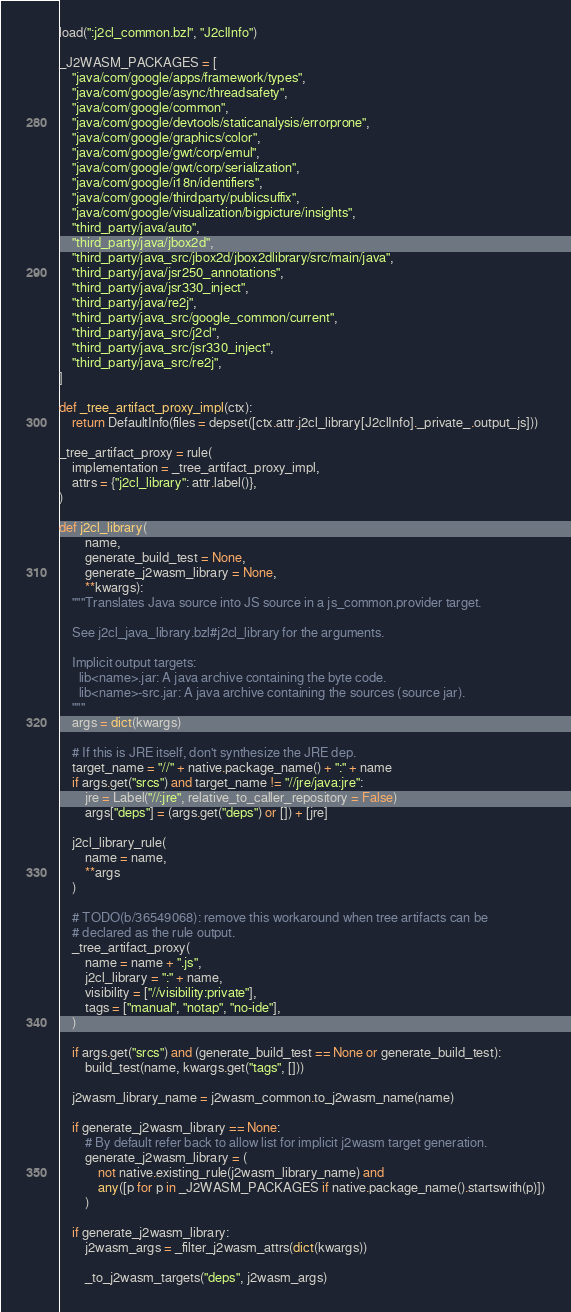Convert code to text. <code><loc_0><loc_0><loc_500><loc_500><_Python_>load(":j2cl_common.bzl", "J2clInfo")

_J2WASM_PACKAGES = [
    "java/com/google/apps/framework/types",
    "java/com/google/async/threadsafety",
    "java/com/google/common",
    "java/com/google/devtools/staticanalysis/errorprone",
    "java/com/google/graphics/color",
    "java/com/google/gwt/corp/emul",
    "java/com/google/gwt/corp/serialization",
    "java/com/google/i18n/identifiers",
    "java/com/google/thirdparty/publicsuffix",
    "java/com/google/visualization/bigpicture/insights",
    "third_party/java/auto",
    "third_party/java/jbox2d",
    "third_party/java_src/jbox2d/jbox2dlibrary/src/main/java",
    "third_party/java/jsr250_annotations",
    "third_party/java/jsr330_inject",
    "third_party/java/re2j",
    "third_party/java_src/google_common/current",
    "third_party/java_src/j2cl",
    "third_party/java_src/jsr330_inject",
    "third_party/java_src/re2j",
]

def _tree_artifact_proxy_impl(ctx):
    return DefaultInfo(files = depset([ctx.attr.j2cl_library[J2clInfo]._private_.output_js]))

_tree_artifact_proxy = rule(
    implementation = _tree_artifact_proxy_impl,
    attrs = {"j2cl_library": attr.label()},
)

def j2cl_library(
        name,
        generate_build_test = None,
        generate_j2wasm_library = None,
        **kwargs):
    """Translates Java source into JS source in a js_common.provider target.

    See j2cl_java_library.bzl#j2cl_library for the arguments.

    Implicit output targets:
      lib<name>.jar: A java archive containing the byte code.
      lib<name>-src.jar: A java archive containing the sources (source jar).
    """
    args = dict(kwargs)

    # If this is JRE itself, don't synthesize the JRE dep.
    target_name = "//" + native.package_name() + ":" + name
    if args.get("srcs") and target_name != "//jre/java:jre":
        jre = Label("//:jre", relative_to_caller_repository = False)
        args["deps"] = (args.get("deps") or []) + [jre]

    j2cl_library_rule(
        name = name,
        **args
    )

    # TODO(b/36549068): remove this workaround when tree artifacts can be
    # declared as the rule output.
    _tree_artifact_proxy(
        name = name + ".js",
        j2cl_library = ":" + name,
        visibility = ["//visibility:private"],
        tags = ["manual", "notap", "no-ide"],
    )

    if args.get("srcs") and (generate_build_test == None or generate_build_test):
        build_test(name, kwargs.get("tags", []))

    j2wasm_library_name = j2wasm_common.to_j2wasm_name(name)

    if generate_j2wasm_library == None:
        # By default refer back to allow list for implicit j2wasm target generation.
        generate_j2wasm_library = (
            not native.existing_rule(j2wasm_library_name) and
            any([p for p in _J2WASM_PACKAGES if native.package_name().startswith(p)])
        )

    if generate_j2wasm_library:
        j2wasm_args = _filter_j2wasm_attrs(dict(kwargs))

        _to_j2wasm_targets("deps", j2wasm_args)</code> 